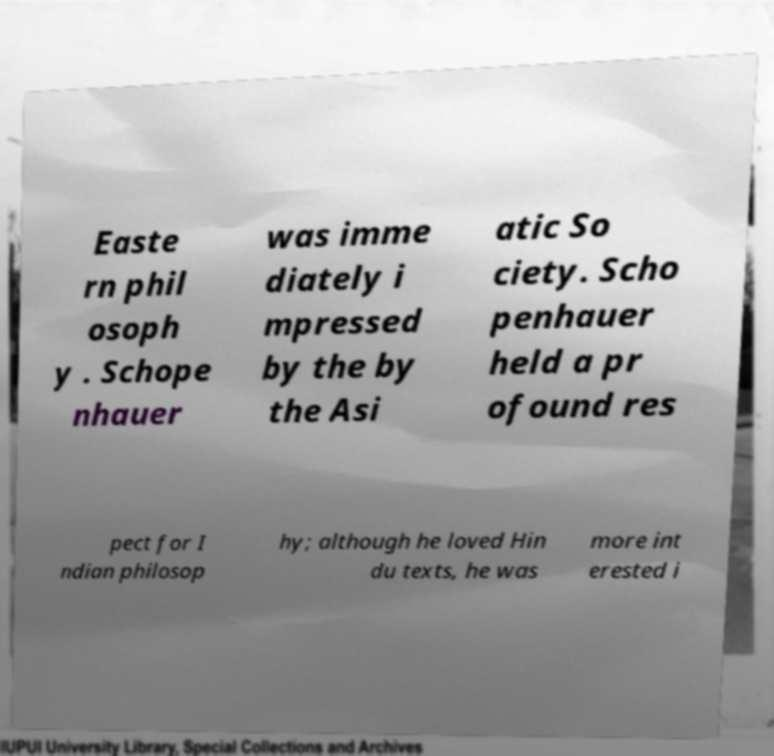There's text embedded in this image that I need extracted. Can you transcribe it verbatim? Easte rn phil osoph y . Schope nhauer was imme diately i mpressed by the by the Asi atic So ciety. Scho penhauer held a pr ofound res pect for I ndian philosop hy; although he loved Hin du texts, he was more int erested i 